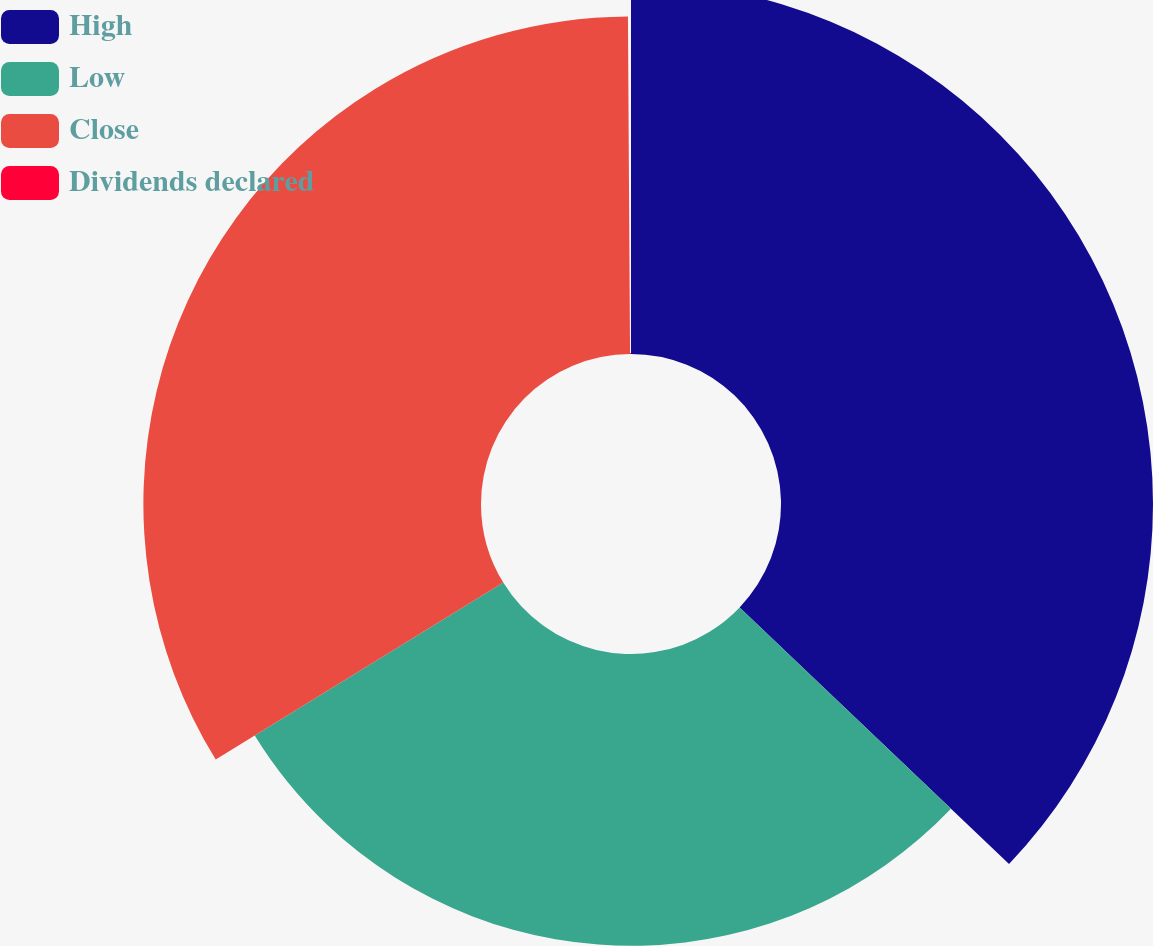<chart> <loc_0><loc_0><loc_500><loc_500><pie_chart><fcel>High<fcel>Low<fcel>Close<fcel>Dividends declared<nl><fcel>37.11%<fcel>29.11%<fcel>33.68%<fcel>0.1%<nl></chart> 